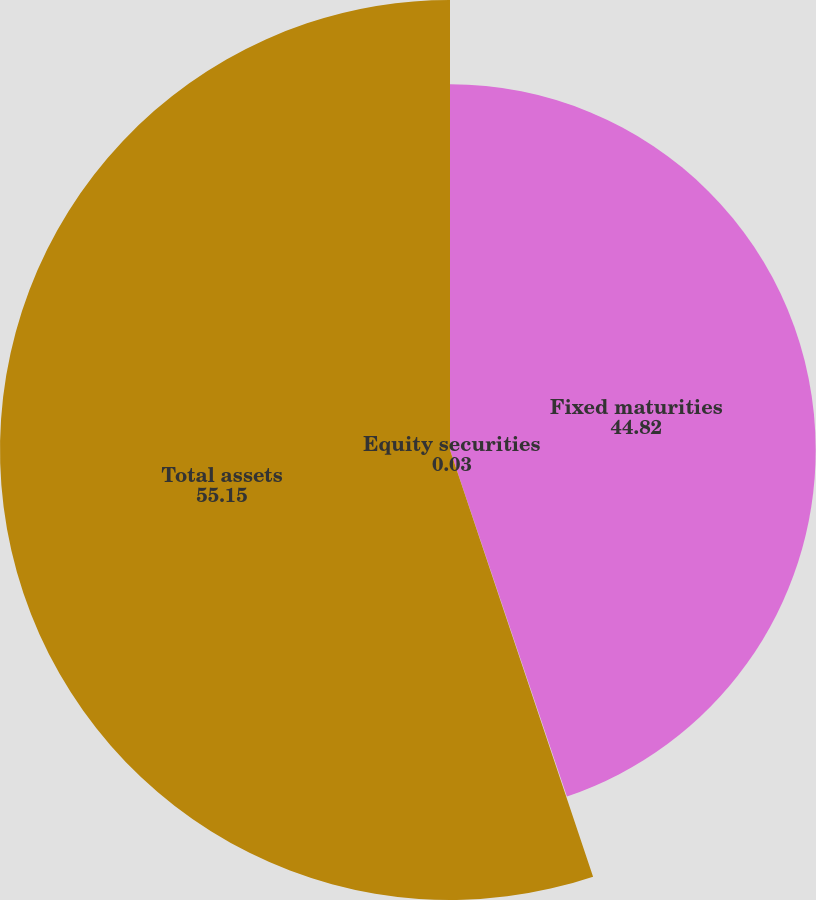<chart> <loc_0><loc_0><loc_500><loc_500><pie_chart><fcel>Fixed maturities<fcel>Equity securities<fcel>Total assets<nl><fcel>44.82%<fcel>0.03%<fcel>55.15%<nl></chart> 